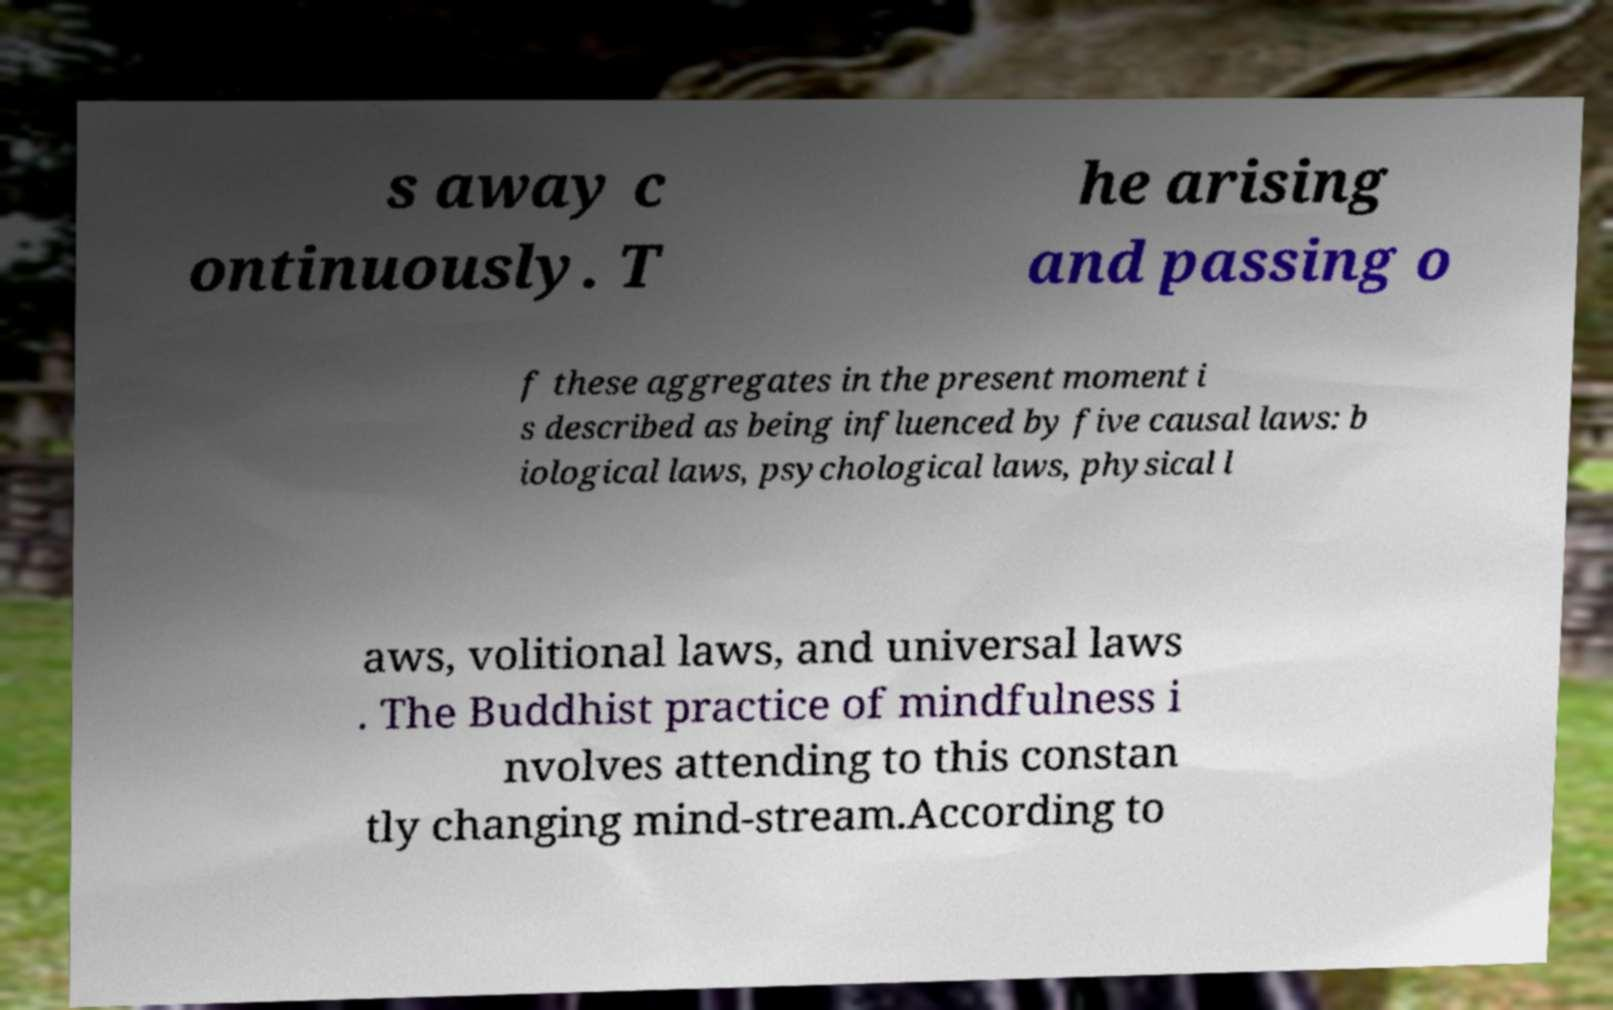There's text embedded in this image that I need extracted. Can you transcribe it verbatim? s away c ontinuously. T he arising and passing o f these aggregates in the present moment i s described as being influenced by five causal laws: b iological laws, psychological laws, physical l aws, volitional laws, and universal laws . The Buddhist practice of mindfulness i nvolves attending to this constan tly changing mind-stream.According to 